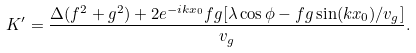<formula> <loc_0><loc_0><loc_500><loc_500>K ^ { \prime } = \frac { \Delta ( f ^ { 2 } + g ^ { 2 } ) + 2 e ^ { - i k x _ { 0 } } f g [ \lambda \cos \phi - f g \sin ( k x _ { 0 } ) / v _ { g } ] } { v _ { g } } .</formula> 